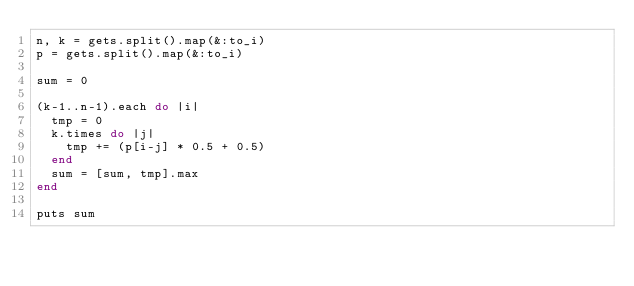Convert code to text. <code><loc_0><loc_0><loc_500><loc_500><_Ruby_>n, k = gets.split().map(&:to_i)
p = gets.split().map(&:to_i)

sum = 0

(k-1..n-1).each do |i|
  tmp = 0
  k.times do |j|
    tmp += (p[i-j] * 0.5 + 0.5)
  end
  sum = [sum, tmp].max
end

puts sum</code> 